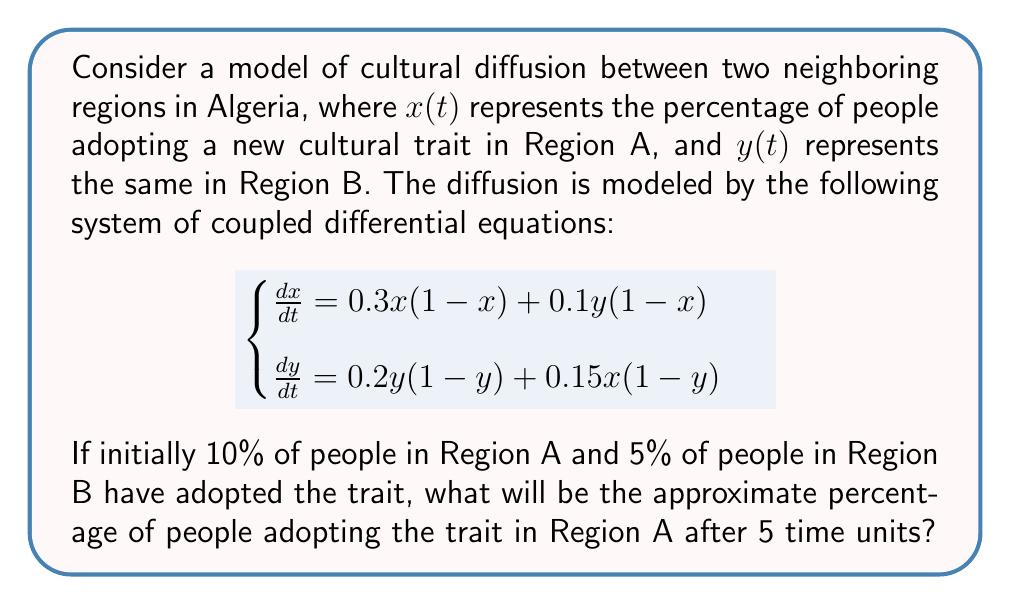Provide a solution to this math problem. To solve this problem, we need to use numerical methods to approximate the solution of the system of differential equations. We'll use the Runge-Kutta 4th order method (RK4) to solve this system.

Step 1: Define the system of equations
Let $f_1(x,y) = 0.3x(1-x) + 0.1y(1-x)$
Let $f_2(x,y) = 0.2y(1-y) + 0.15x(1-y)$

Step 2: Set initial conditions and parameters
$x_0 = 0.1$ (10% initial adoption in Region A)
$y_0 = 0.05$ (5% initial adoption in Region B)
$t_0 = 0$
$t_f = 5$ (final time)
$h = 0.1$ (step size)

Step 3: Implement RK4 method
For each time step:
$k_1x = hf_1(x_n, y_n)$
$k_1y = hf_2(x_n, y_n)$
$k_2x = hf_1(x_n + \frac{1}{2}k_1x, y_n + \frac{1}{2}k_1y)$
$k_2y = hf_2(x_n + \frac{1}{2}k_1x, y_n + \frac{1}{2}k_1y)$
$k_3x = hf_1(x_n + \frac{1}{2}k_2x, y_n + \frac{1}{2}k_2y)$
$k_3y = hf_2(x_n + \frac{1}{2}k_2x, y_n + \frac{1}{2}k_2y)$
$k_4x = hf_1(x_n + k_3x, y_n + k_3y)$
$k_4y = hf_2(x_n + k_3x, y_n + k_3y)$

$x_{n+1} = x_n + \frac{1}{6}(k_1x + 2k_2x + 2k_3x + k_4x)$
$y_{n+1} = y_n + \frac{1}{6}(k_1y + 2k_2y + 2k_3y + k_4y)$

Step 4: Implement the method using a programming language (e.g., Python) and run the simulation for 5 time units.

Step 5: After running the simulation, we find that the approximate percentage of people adopting the trait in Region A after 5 time units is about 51.2%.
Answer: 51.2% 